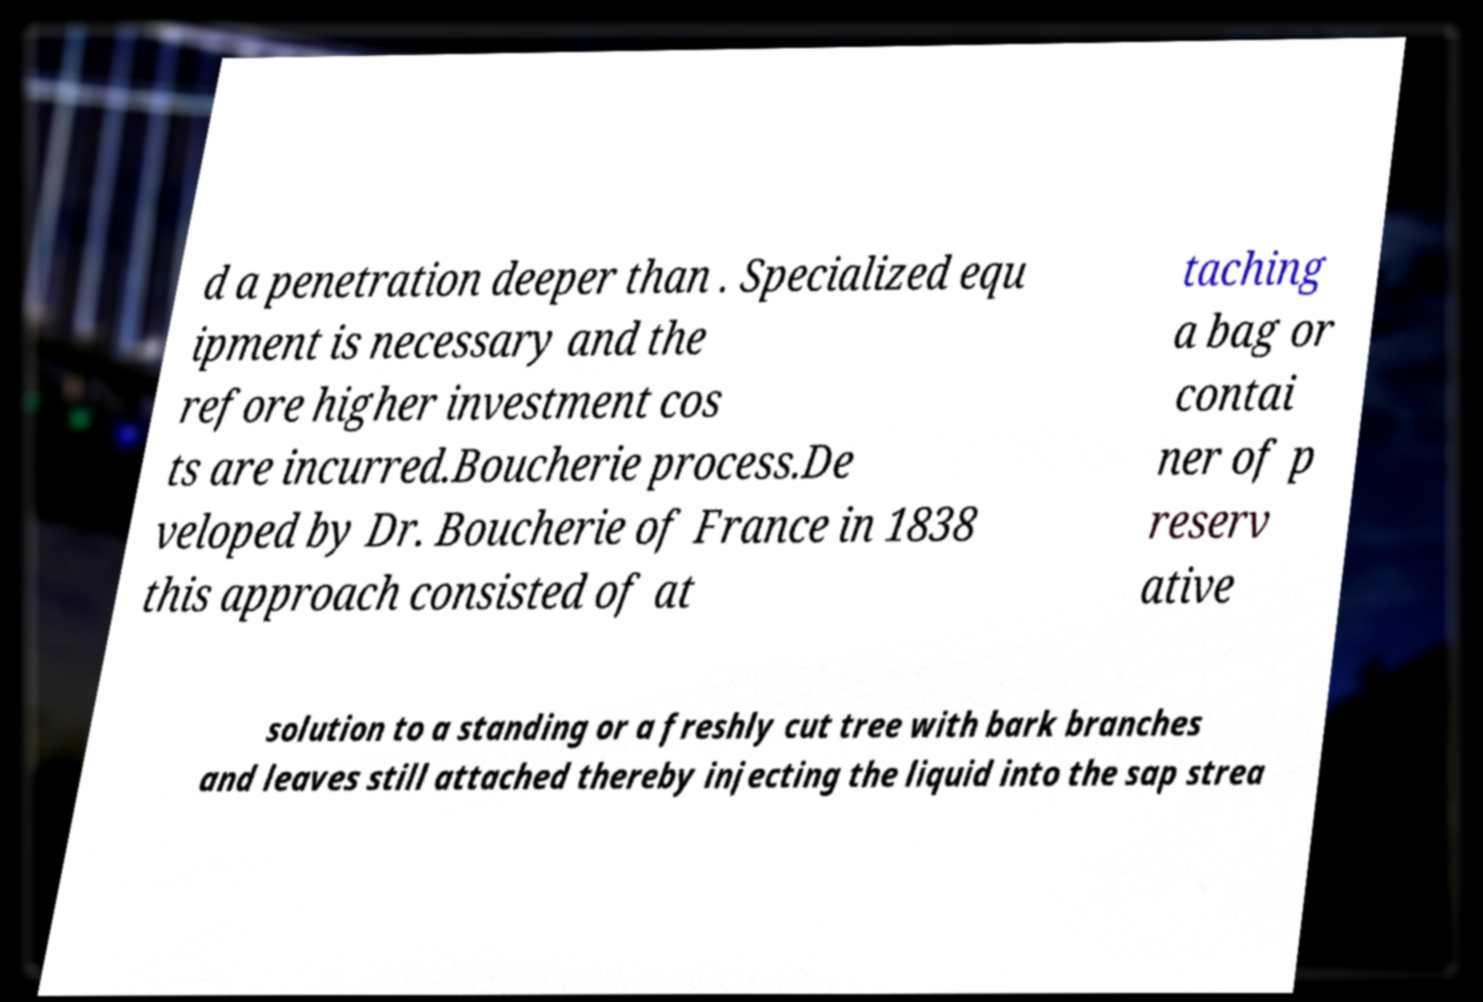I need the written content from this picture converted into text. Can you do that? d a penetration deeper than . Specialized equ ipment is necessary and the refore higher investment cos ts are incurred.Boucherie process.De veloped by Dr. Boucherie of France in 1838 this approach consisted of at taching a bag or contai ner of p reserv ative solution to a standing or a freshly cut tree with bark branches and leaves still attached thereby injecting the liquid into the sap strea 